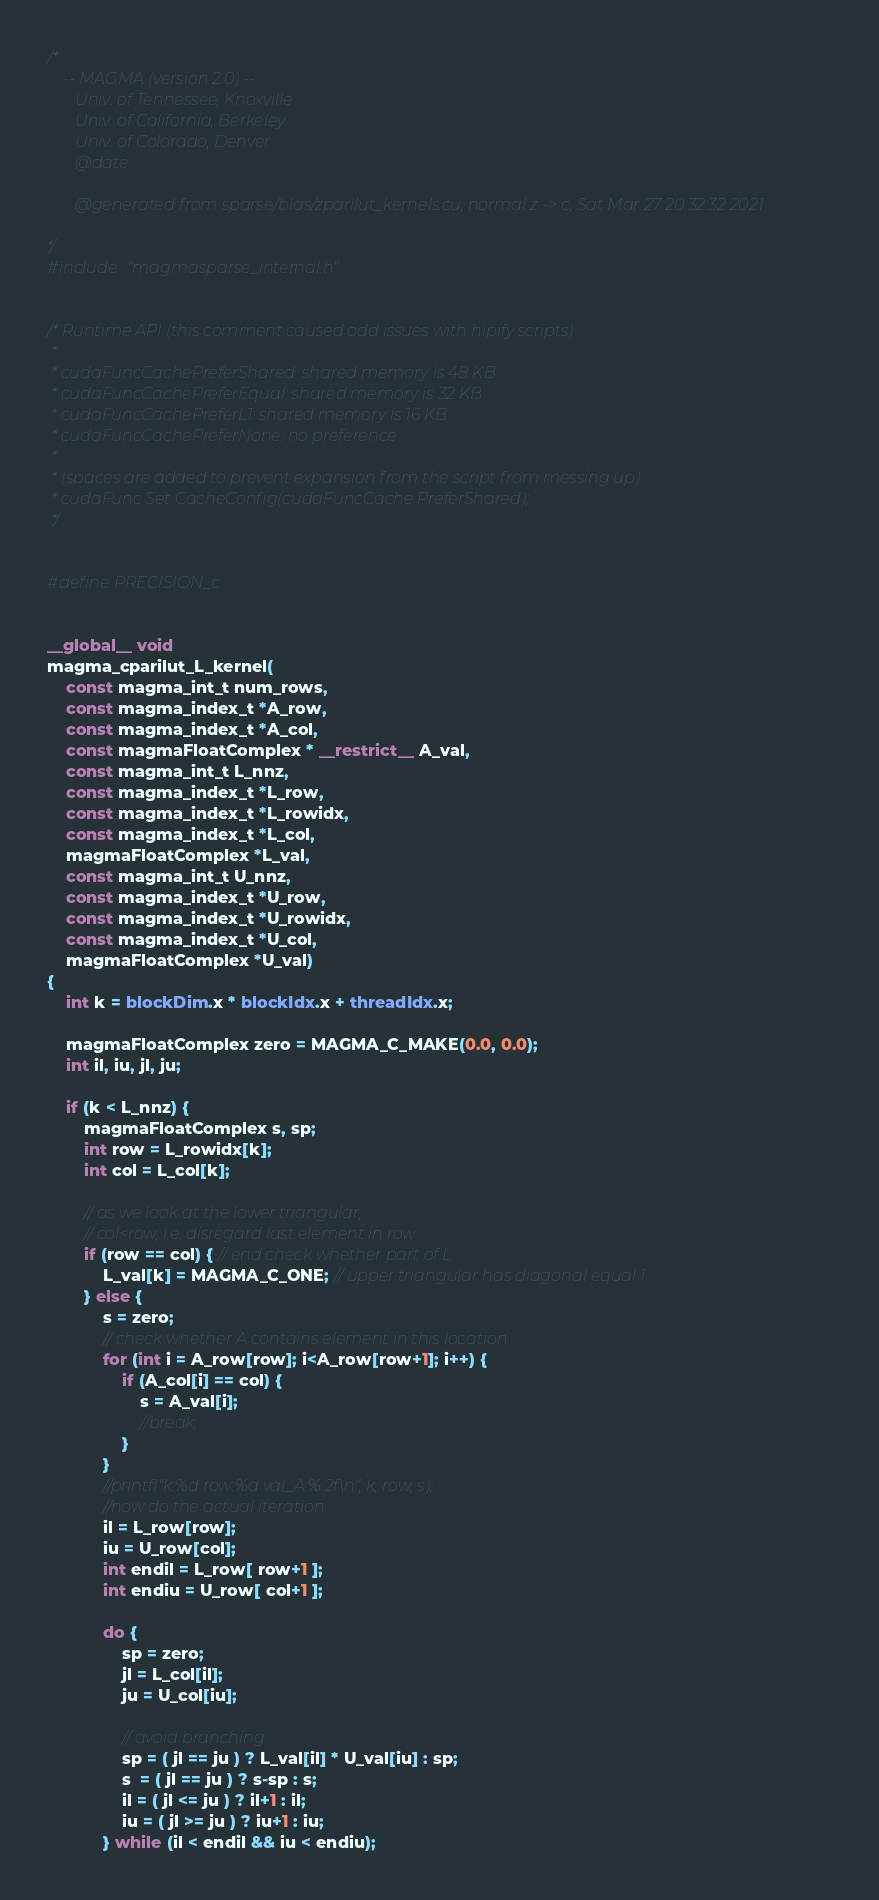<code> <loc_0><loc_0><loc_500><loc_500><_Cuda_>/*
    -- MAGMA (version 2.0) --
       Univ. of Tennessee, Knoxville
       Univ. of California, Berkeley
       Univ. of Colorado, Denver
       @date

       @generated from sparse/blas/zparilut_kernels.cu, normal z -> c, Sat Mar 27 20:32:32 2021

*/
#include "magmasparse_internal.h"


/* Runtime API (this comment caused odd issues with hipify scripts) 
 *
 * cudaFuncCachePreferShared: shared memory is 48 KB
 * cudaFuncCachePreferEqual: shared memory is 32 KB
 * cudaFuncCachePreferL1: shared memory is 16 KB
 * cudaFuncCachePreferNone: no preference
 *
 * (spaces are added to prevent expansion from the script from messing up)
 * cudaFunc Set CacheConfig(cudaFuncCache PreferShared);
 */


#define PRECISION_c


__global__ void 
magma_cparilut_L_kernel(   
    const magma_int_t num_rows, 
    const magma_index_t *A_row,  
    const magma_index_t *A_col,  
    const magmaFloatComplex * __restrict__ A_val, 
    const magma_int_t L_nnz, 
    const magma_index_t *L_row, 
    const magma_index_t *L_rowidx, 
    const magma_index_t *L_col, 
    magmaFloatComplex *L_val, 
    const magma_int_t U_nnz, 
    const magma_index_t *U_row, 
    const magma_index_t *U_rowidx, 
    const magma_index_t *U_col, 
    magmaFloatComplex *U_val)
{
    int k = blockDim.x * blockIdx.x + threadIdx.x;

    magmaFloatComplex zero = MAGMA_C_MAKE(0.0, 0.0);
    int il, iu, jl, ju;
    
    if (k < L_nnz) {
        magmaFloatComplex s, sp;
        int row = L_rowidx[k];
        int col = L_col[k];

        // as we look at the lower triangular,
        // col<row, i.e. disregard last element in row
        if (row == col) { // end check whether part of L
            L_val[k] = MAGMA_C_ONE; // upper triangular has diagonal equal 1
        } else {
            s = zero;
            // check whether A contains element in this location
            for (int i = A_row[row]; i<A_row[row+1]; i++) {
                if (A_col[i] == col) {
                    s = A_val[i];
                    //break;
                }
            }
            //printf("k:%d row:%d val_A:%.2f\n", k, row, s);
            //now do the actual iteration
            il = L_row[row];
            iu = U_row[col];
            int endil = L_row[ row+1 ];
            int endiu = U_row[ col+1 ]; 
            
            do {
                sp = zero;
                jl = L_col[il];
                ju = U_col[iu];
    
                // avoid branching
                sp = ( jl == ju ) ? L_val[il] * U_val[iu] : sp;
                s  = ( jl == ju ) ? s-sp : s;
                il = ( jl <= ju ) ? il+1 : il;
                iu = ( jl >= ju ) ? iu+1 : iu;
            } while (il < endil && iu < endiu);</code> 